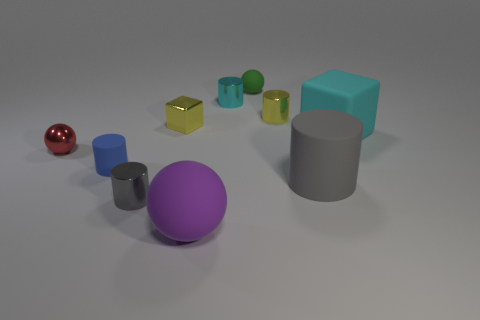Is the shape of the big matte object that is in front of the gray rubber cylinder the same as the matte object that is to the left of the gray metal thing?
Keep it short and to the point. No. Is there a small red cylinder made of the same material as the tiny gray cylinder?
Your answer should be very brief. No. What is the color of the big block?
Give a very brief answer. Cyan. What size is the sphere on the left side of the small yellow metal cube?
Offer a terse response. Small. What number of tiny things are the same color as the small matte cylinder?
Ensure brevity in your answer.  0. Is there a purple object that is behind the matte cylinder to the right of the cyan shiny cylinder?
Offer a terse response. No. There is a matte cylinder in front of the blue rubber object; does it have the same color as the tiny matte object that is in front of the red sphere?
Ensure brevity in your answer.  No. What color is the rubber cylinder that is the same size as the gray metallic cylinder?
Provide a short and direct response. Blue. Is the number of things that are on the left side of the gray shiny cylinder the same as the number of large gray cylinders left of the purple object?
Your response must be concise. No. There is a sphere behind the sphere that is on the left side of the small gray metallic cylinder; what is it made of?
Your response must be concise. Rubber. 